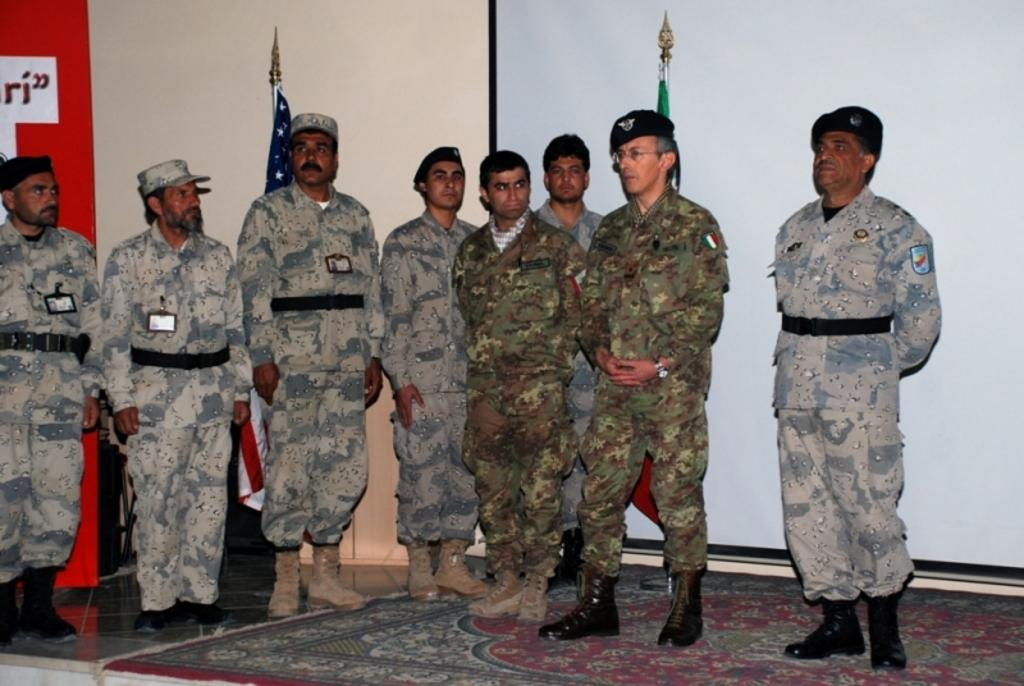What is happening in the image? There is a group of people standing in the image. What can be seen on the floor in the image? There is a carpet on the floor in the image. What is visible in the background of the image? Flags, a projector screen, a banner, and a wall are visible in the background of the image. What type of lettuce is being served on the marble table in the image? There is no lettuce or marble table present in the image. 